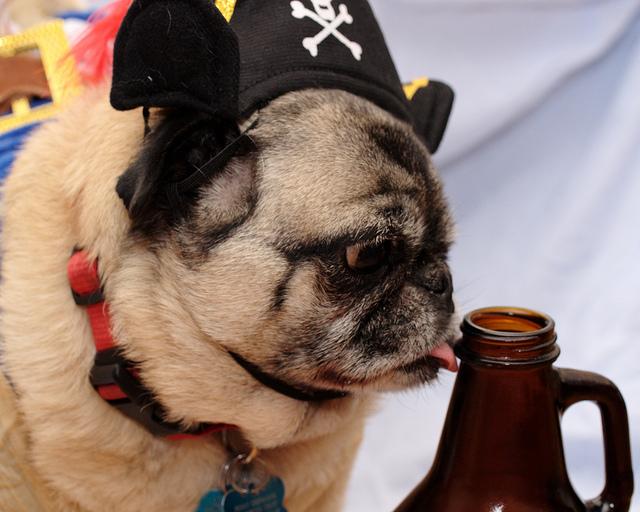What does the dog have on its head?
Keep it brief. Pirate hat. Is the dog thirsty?
Keep it brief. Yes. Is this indoors?
Be succinct. No. 